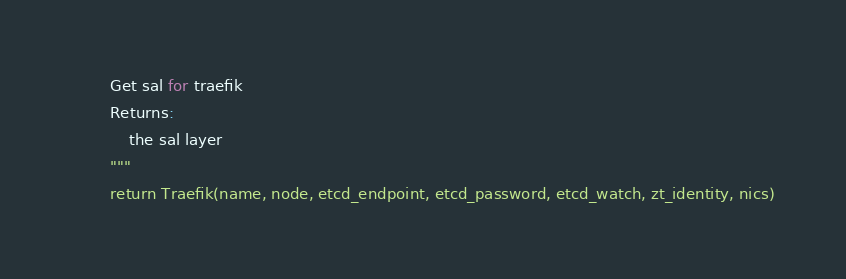Convert code to text. <code><loc_0><loc_0><loc_500><loc_500><_Python_>        Get sal for traefik
        Returns:
            the sal layer
        """
        return Traefik(name, node, etcd_endpoint, etcd_password, etcd_watch, zt_identity, nics)
</code> 